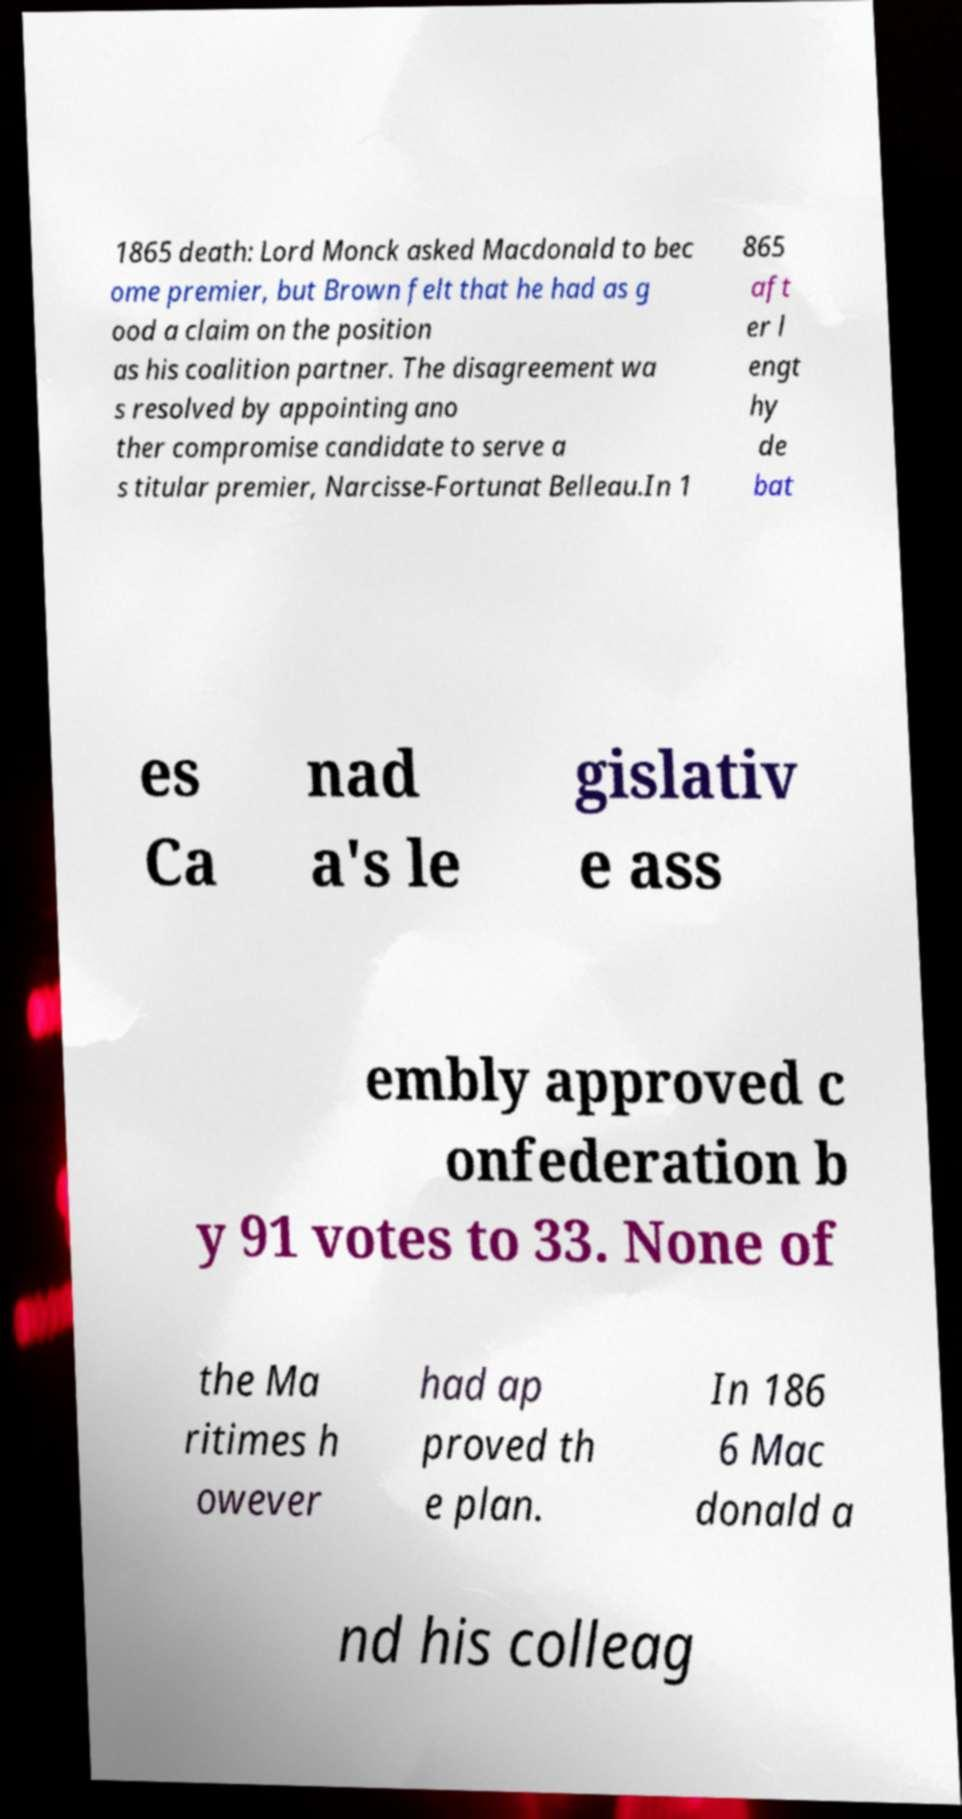Please identify and transcribe the text found in this image. 1865 death: Lord Monck asked Macdonald to bec ome premier, but Brown felt that he had as g ood a claim on the position as his coalition partner. The disagreement wa s resolved by appointing ano ther compromise candidate to serve a s titular premier, Narcisse-Fortunat Belleau.In 1 865 aft er l engt hy de bat es Ca nad a's le gislativ e ass embly approved c onfederation b y 91 votes to 33. None of the Ma ritimes h owever had ap proved th e plan. In 186 6 Mac donald a nd his colleag 